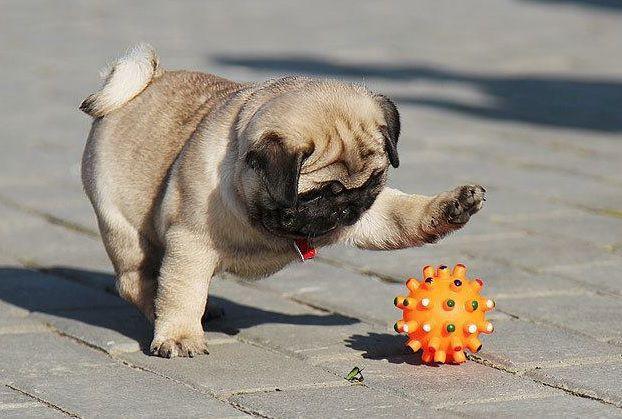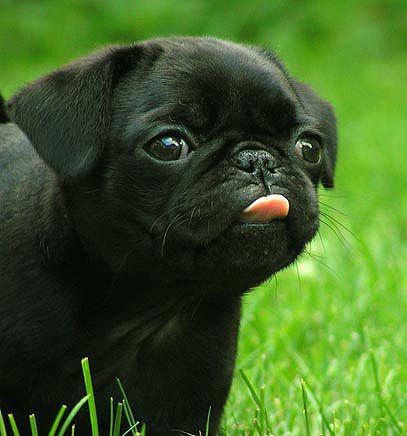The first image is the image on the left, the second image is the image on the right. Examine the images to the left and right. Is the description "At least one of the dogs is playing with a ball that has spikes on it." accurate? Answer yes or no. Yes. The first image is the image on the left, the second image is the image on the right. Examine the images to the left and right. Is the description "There are two dogs." accurate? Answer yes or no. Yes. 